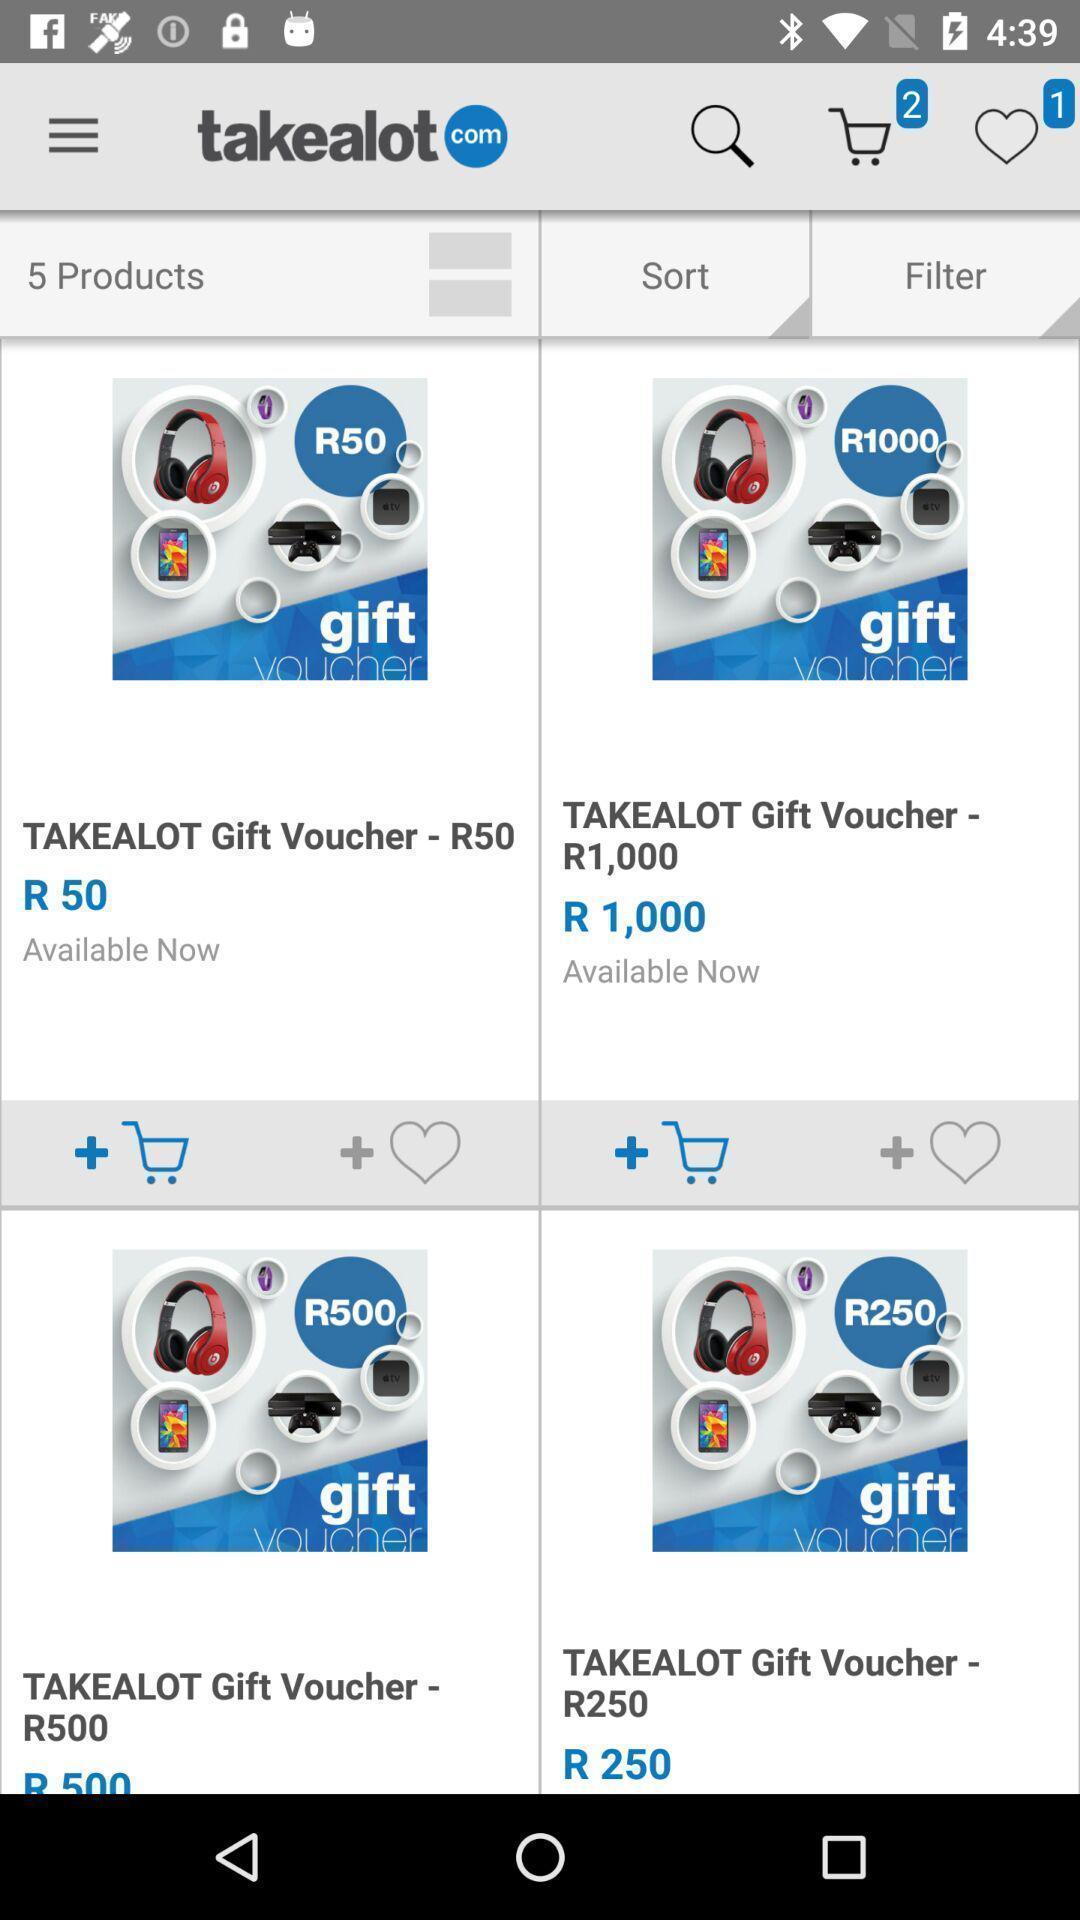Explain what's happening in this screen capture. Screen showing list of products in e-commerce app. 